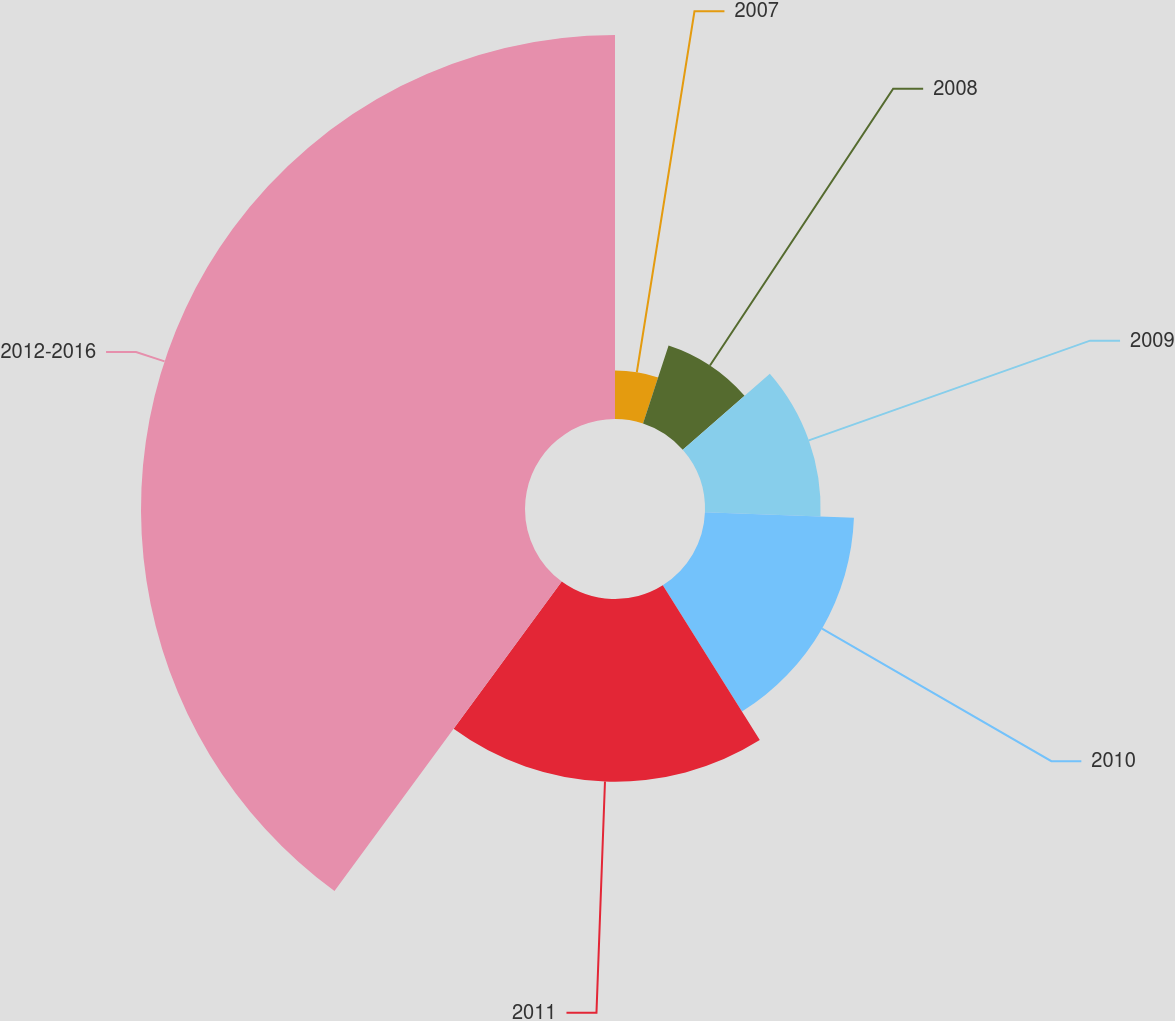Convert chart. <chart><loc_0><loc_0><loc_500><loc_500><pie_chart><fcel>2007<fcel>2008<fcel>2009<fcel>2010<fcel>2011<fcel>2012-2016<nl><fcel>5.04%<fcel>8.53%<fcel>12.02%<fcel>15.5%<fcel>18.99%<fcel>39.92%<nl></chart> 